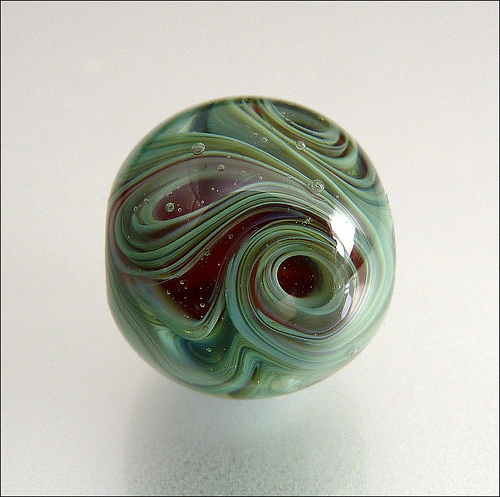<image>
Can you confirm if the swirl is in the marble? Yes. The swirl is contained within or inside the marble, showing a containment relationship. 